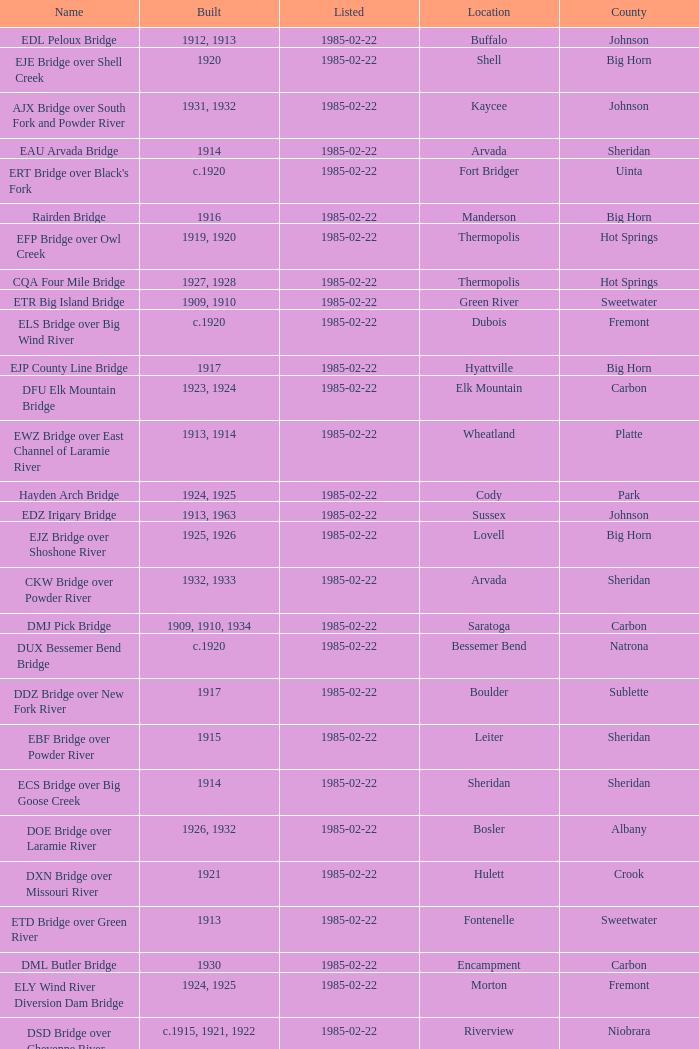In what year was the bridge in Lovell built? 1925, 1926. 